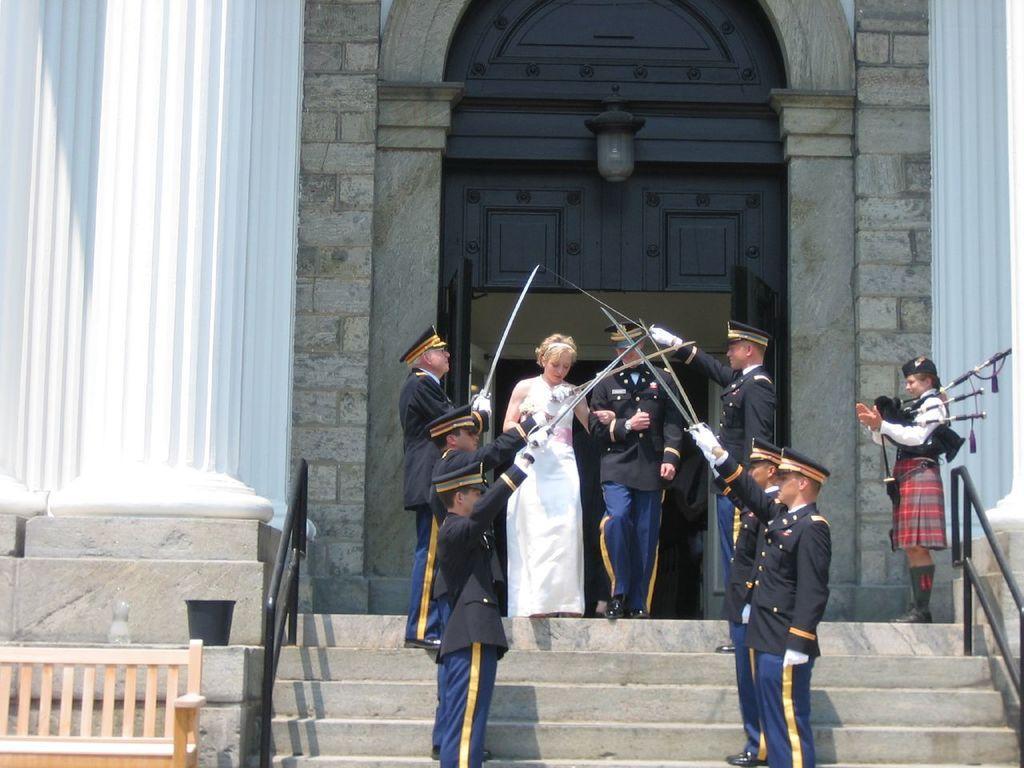How would you summarize this image in a sentence or two? In the background we can see the pillars, door, light, wall. In this picture we can see the people holding objects and we can see a woman, man holding their hands. We can see the stairs and the railing. On the left side of the picture we can see a pot and a wooden bench. 